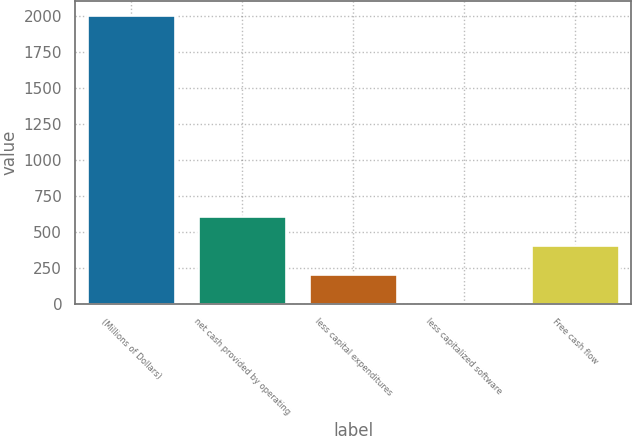Convert chart. <chart><loc_0><loc_0><loc_500><loc_500><bar_chart><fcel>(Millions of Dollars)<fcel>net cash provided by operating<fcel>less capital expenditures<fcel>less capitalized software<fcel>Free cash flow<nl><fcel>2004<fcel>606.1<fcel>206.7<fcel>7<fcel>406.4<nl></chart> 